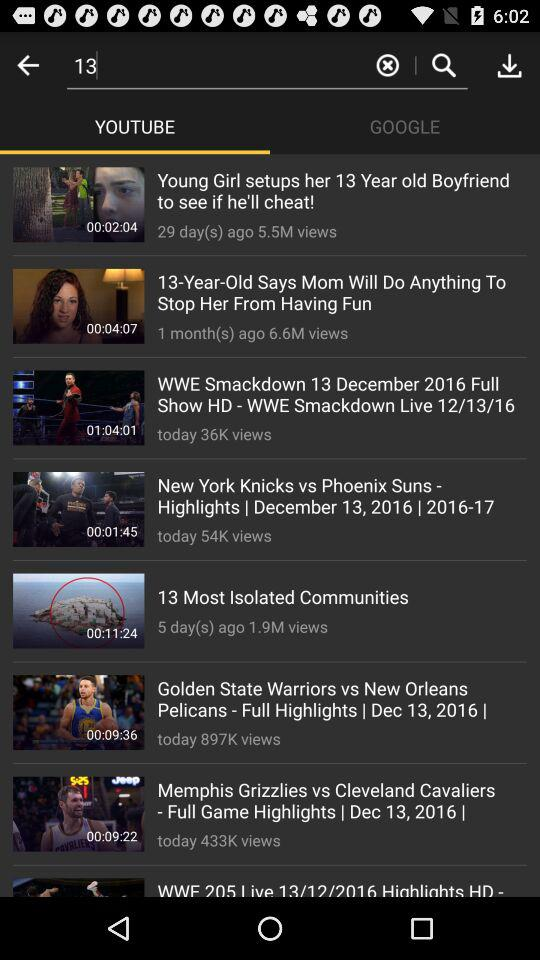What video has 1.9 million views? The video is "13 Most Isolated Communities". 